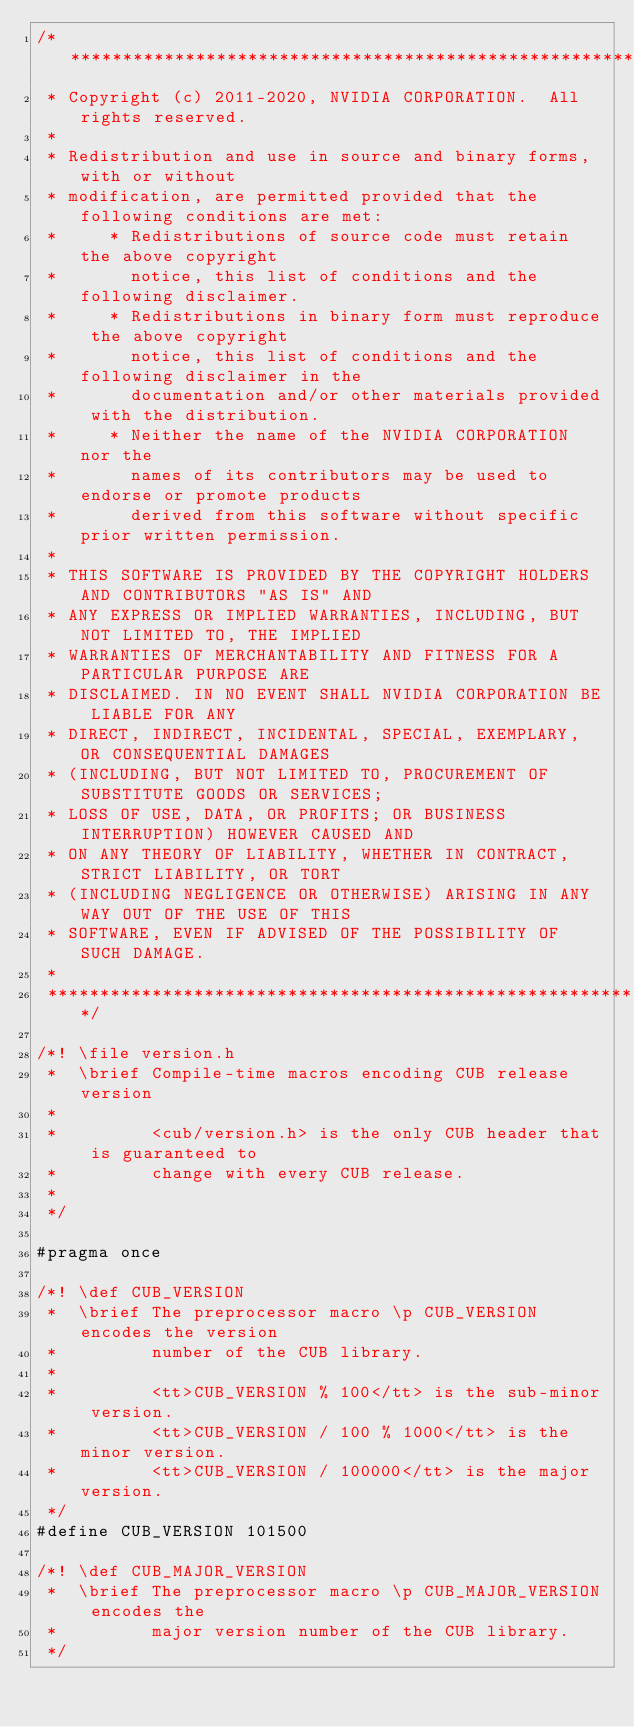<code> <loc_0><loc_0><loc_500><loc_500><_Cuda_>/******************************************************************************
 * Copyright (c) 2011-2020, NVIDIA CORPORATION.  All rights reserved.
 *
 * Redistribution and use in source and binary forms, with or without
 * modification, are permitted provided that the following conditions are met:
 *     * Redistributions of source code must retain the above copyright
 *       notice, this list of conditions and the following disclaimer.
 *     * Redistributions in binary form must reproduce the above copyright
 *       notice, this list of conditions and the following disclaimer in the
 *       documentation and/or other materials provided with the distribution.
 *     * Neither the name of the NVIDIA CORPORATION nor the
 *       names of its contributors may be used to endorse or promote products
 *       derived from this software without specific prior written permission.
 *
 * THIS SOFTWARE IS PROVIDED BY THE COPYRIGHT HOLDERS AND CONTRIBUTORS "AS IS" AND
 * ANY EXPRESS OR IMPLIED WARRANTIES, INCLUDING, BUT NOT LIMITED TO, THE IMPLIED
 * WARRANTIES OF MERCHANTABILITY AND FITNESS FOR A PARTICULAR PURPOSE ARE
 * DISCLAIMED. IN NO EVENT SHALL NVIDIA CORPORATION BE LIABLE FOR ANY
 * DIRECT, INDIRECT, INCIDENTAL, SPECIAL, EXEMPLARY, OR CONSEQUENTIAL DAMAGES
 * (INCLUDING, BUT NOT LIMITED TO, PROCUREMENT OF SUBSTITUTE GOODS OR SERVICES;
 * LOSS OF USE, DATA, OR PROFITS; OR BUSINESS INTERRUPTION) HOWEVER CAUSED AND
 * ON ANY THEORY OF LIABILITY, WHETHER IN CONTRACT, STRICT LIABILITY, OR TORT
 * (INCLUDING NEGLIGENCE OR OTHERWISE) ARISING IN ANY WAY OUT OF THE USE OF THIS
 * SOFTWARE, EVEN IF ADVISED OF THE POSSIBILITY OF SUCH DAMAGE.
 *
 ******************************************************************************/

/*! \file version.h
 *  \brief Compile-time macros encoding CUB release version
 *
 *         <cub/version.h> is the only CUB header that is guaranteed to
 *         change with every CUB release.
 *
 */

#pragma once

/*! \def CUB_VERSION
 *  \brief The preprocessor macro \p CUB_VERSION encodes the version
 *         number of the CUB library.
 *
 *         <tt>CUB_VERSION % 100</tt> is the sub-minor version.
 *         <tt>CUB_VERSION / 100 % 1000</tt> is the minor version.
 *         <tt>CUB_VERSION / 100000</tt> is the major version.
 */
#define CUB_VERSION 101500

/*! \def CUB_MAJOR_VERSION
 *  \brief The preprocessor macro \p CUB_MAJOR_VERSION encodes the
 *         major version number of the CUB library.
 */</code> 